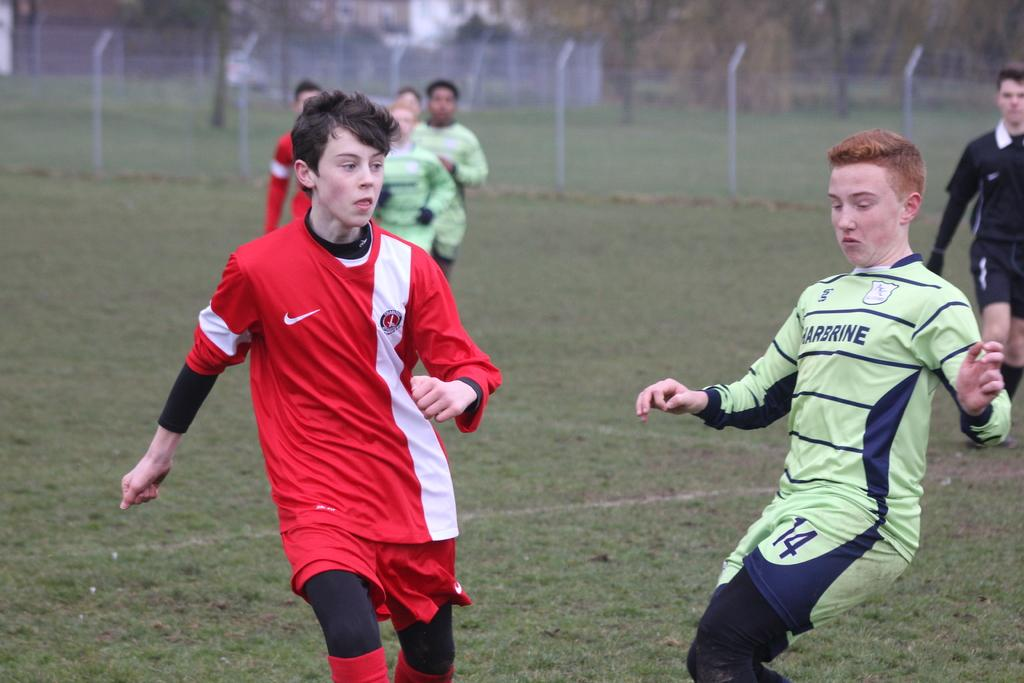<image>
Offer a succinct explanation of the picture presented. Two teams playing a soccer game one with a red uniform and the other one with a green uniform advertising Harbrine. 